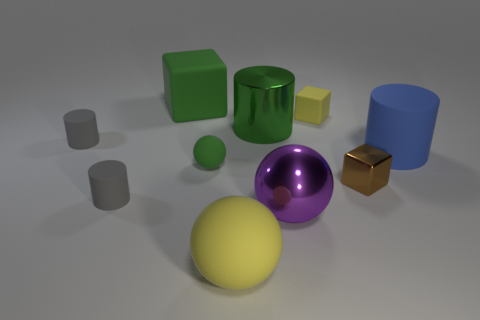How many green things are large matte spheres or tiny matte blocks? Within the image, there is only one large matte sphere which is yellow, not green, and there are no tiny matte blocks. Therefore, there are zero green things that are either large matte spheres or tiny matte blocks. 